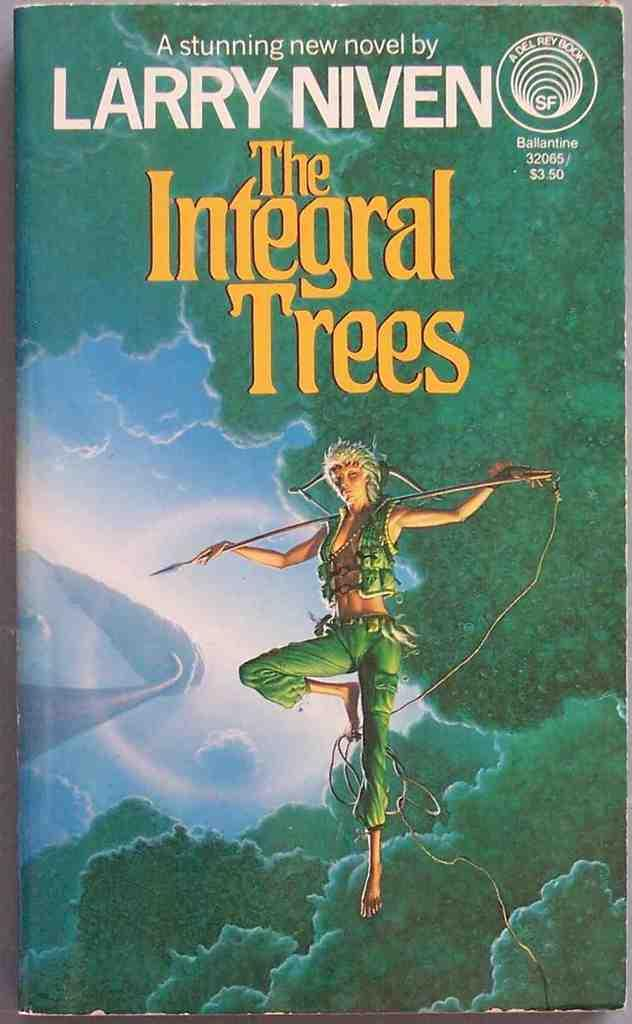<image>
Share a concise interpretation of the image provided. An elf looking figure is on a book cover of The Integral Trees. 